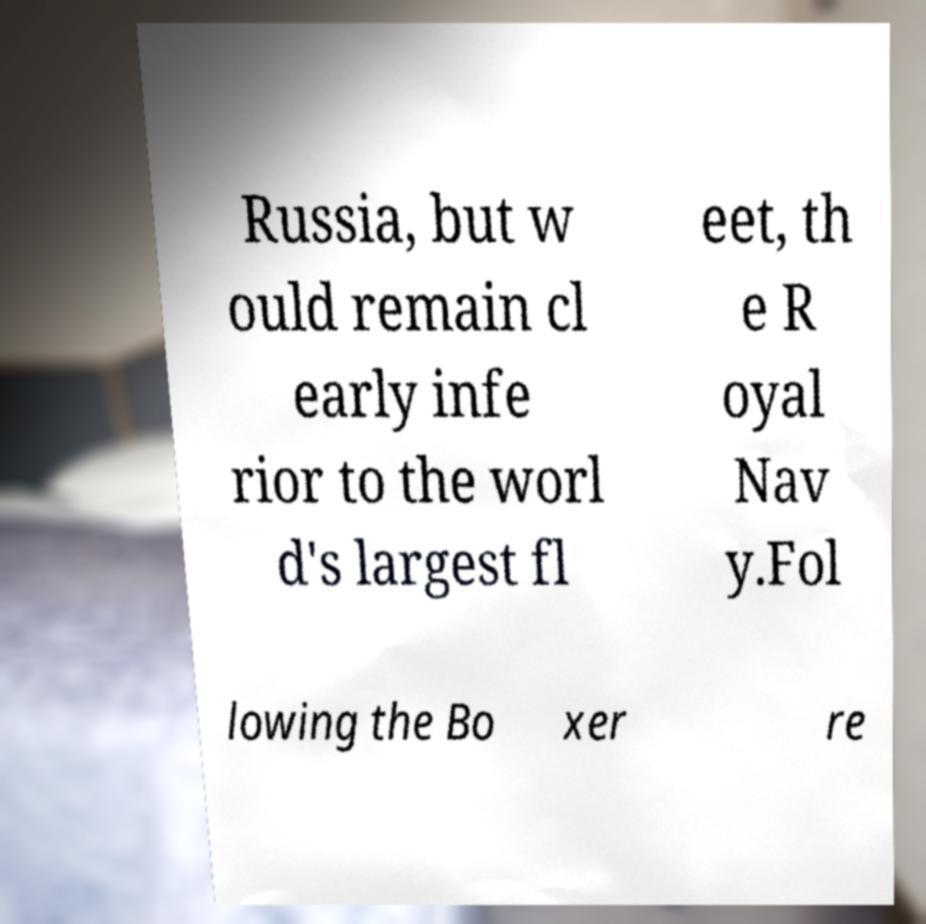Can you read and provide the text displayed in the image?This photo seems to have some interesting text. Can you extract and type it out for me? Russia, but w ould remain cl early infe rior to the worl d's largest fl eet, th e R oyal Nav y.Fol lowing the Bo xer re 